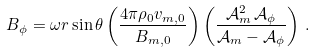Convert formula to latex. <formula><loc_0><loc_0><loc_500><loc_500>B _ { \phi } = \omega r \sin \theta \left ( \frac { 4 \pi \rho _ { 0 } v _ { m , 0 } } { B _ { m , 0 } } \right ) \left ( \frac { \mathcal { A } _ { m } ^ { 2 } \, \mathcal { A } _ { \phi } } { \mathcal { A } _ { m } - \mathcal { A } _ { \phi } } \right ) \, .</formula> 